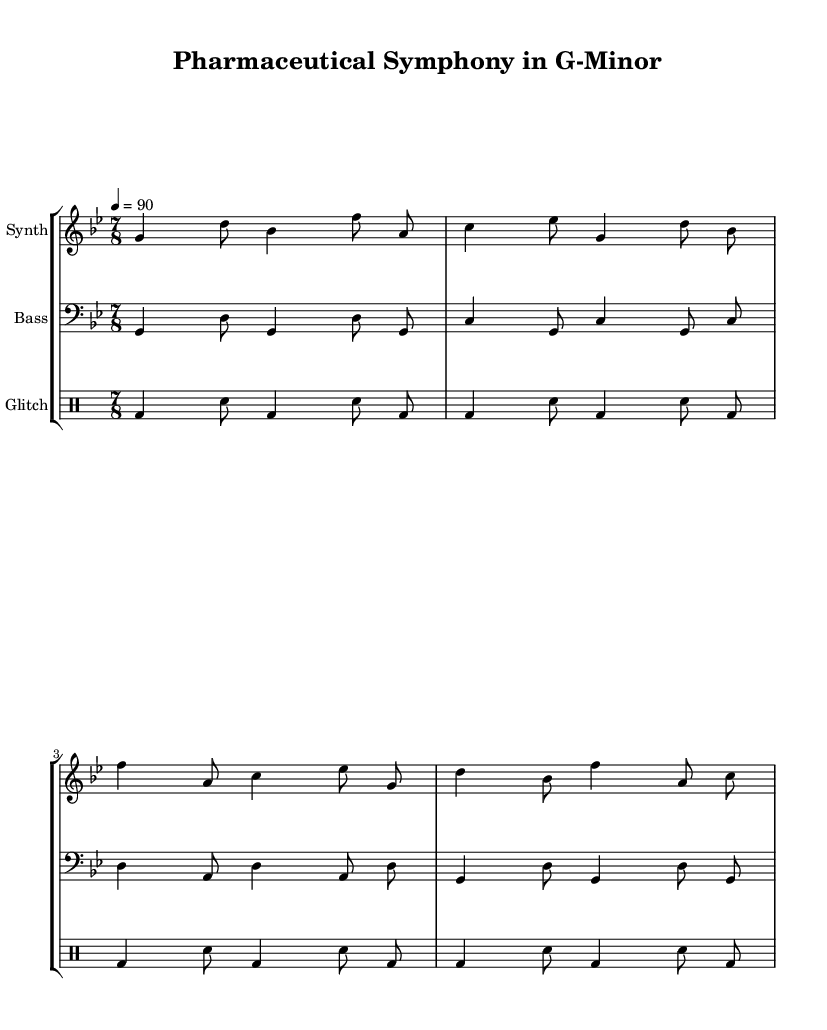What is the key signature of this music? The key signature is indicated by the two flats shown at the beginning of the staff, which corresponds to G minor.
Answer: G minor What is the time signature of this piece? The time signature is located at the beginning of the piece and is represented as 7/8, suggesting seven eighth notes per measure.
Answer: 7/8 What is the tempo marking of this composition? The tempo marking is written as a metronome indication at the start, showing that the piece should be played at 90 beats per minute.
Answer: 90 How many measures are in the synthesizer part? By counting the vertical lines or bar lines within the synthesizer staff, we can determine the number of measures. There are four measures in total.
Answer: 4 What type of rhythm is primarily used in the glitch percussion? Looking at the pattern of quarter notes and eighth notes in the glitch percussion staff, we see that it alternates regularly between bass drum and snare in a repetitive style.
Answer: Repetitive What is the relationship between the synthesizer and electric bass in terms of pitch? Observing the notes in the synthesizer and electric bass parts, we can see that they often play in harmony or parallel motion, particularly with frequent use of G and D notes.
Answer: Harmony What is the overall mood conveyed by the use of 7/8 time signature in this composition? The use of an irregular time signature like 7/8 often evokes a sense of complexity and unpredictability, which aligns with the experimental nature of the piece.
Answer: Unpredictability 